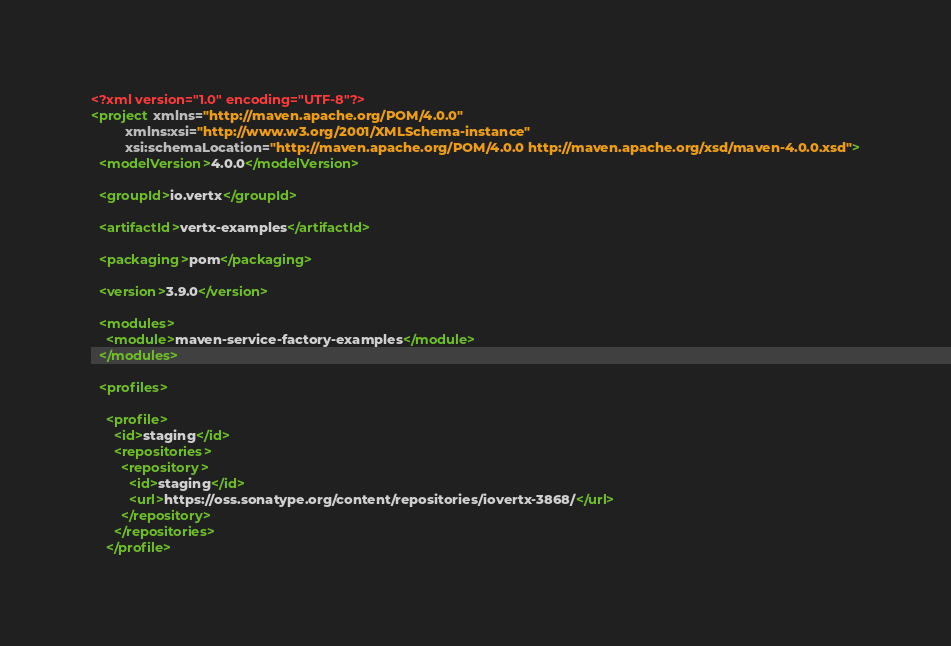Convert code to text. <code><loc_0><loc_0><loc_500><loc_500><_XML_><?xml version="1.0" encoding="UTF-8"?>
<project xmlns="http://maven.apache.org/POM/4.0.0"
         xmlns:xsi="http://www.w3.org/2001/XMLSchema-instance"
         xsi:schemaLocation="http://maven.apache.org/POM/4.0.0 http://maven.apache.org/xsd/maven-4.0.0.xsd">
  <modelVersion>4.0.0</modelVersion>

  <groupId>io.vertx</groupId>

  <artifactId>vertx-examples</artifactId>

  <packaging>pom</packaging>

  <version>3.9.0</version>

  <modules>
    <module>maven-service-factory-examples</module>
  </modules>

  <profiles>

    <profile>
      <id>staging</id>
      <repositories>
        <repository>
          <id>staging</id>
          <url>https://oss.sonatype.org/content/repositories/iovertx-3868/</url>
        </repository>
      </repositories>
    </profile></code> 